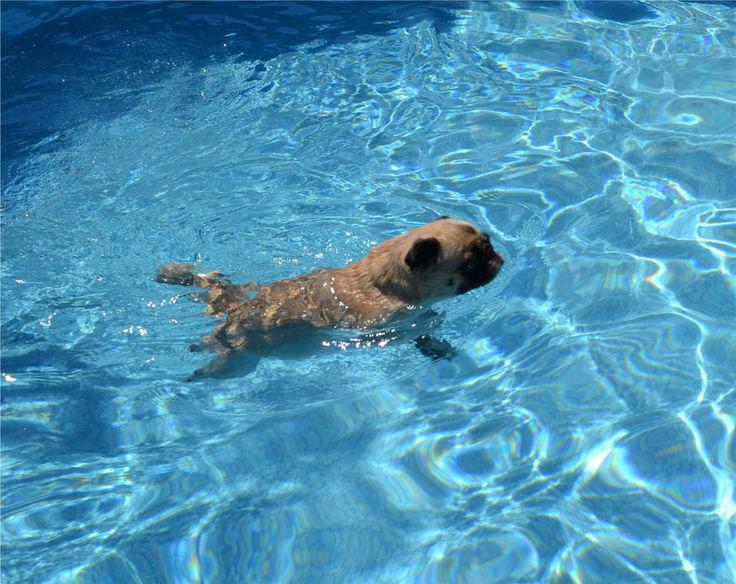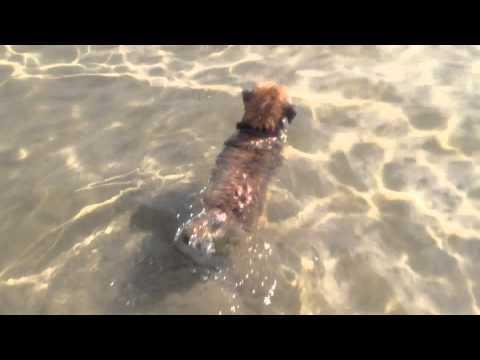The first image is the image on the left, the second image is the image on the right. For the images shown, is this caption "A dog is in the water with a man." true? Answer yes or no. No. The first image is the image on the left, the second image is the image on the right. For the images displayed, is the sentence "There is a human in the water with at least one dog in the picture on the left." factually correct? Answer yes or no. No. 